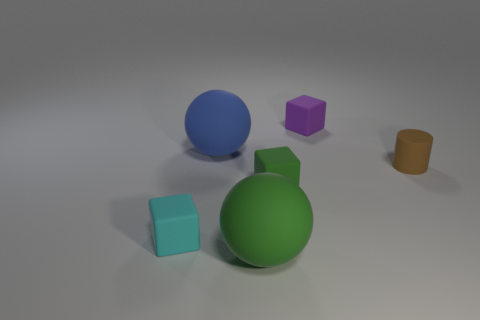The thing that is on the right side of the blue object and in front of the small green rubber object is what color?
Your answer should be very brief. Green. How many objects are either tiny gray rubber cylinders or spheres?
Make the answer very short. 2. What number of large objects are green spheres or brown things?
Offer a very short reply. 1. How big is the thing that is both left of the small green thing and behind the small brown object?
Offer a terse response. Large. How many other objects are there of the same material as the green ball?
Provide a short and direct response. 5. What shape is the matte object that is both in front of the purple thing and behind the brown rubber cylinder?
Offer a very short reply. Sphere. Is the color of the cylinder the same as the small cube that is in front of the tiny green cube?
Offer a very short reply. No. There is a matte block on the left side of the blue object; does it have the same size as the blue rubber ball?
Offer a terse response. No. There is a green thing that is the same shape as the cyan thing; what material is it?
Your answer should be compact. Rubber. Is the small green thing the same shape as the cyan thing?
Make the answer very short. Yes. 